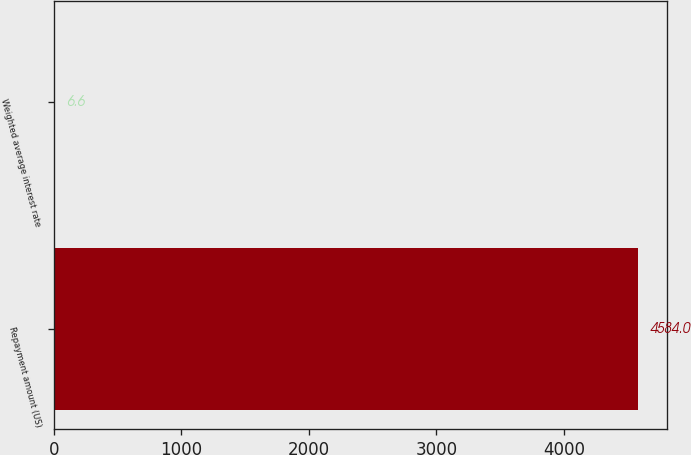<chart> <loc_0><loc_0><loc_500><loc_500><bar_chart><fcel>Repayment amount (US)<fcel>Weighted average interest rate<nl><fcel>4584<fcel>6.6<nl></chart> 